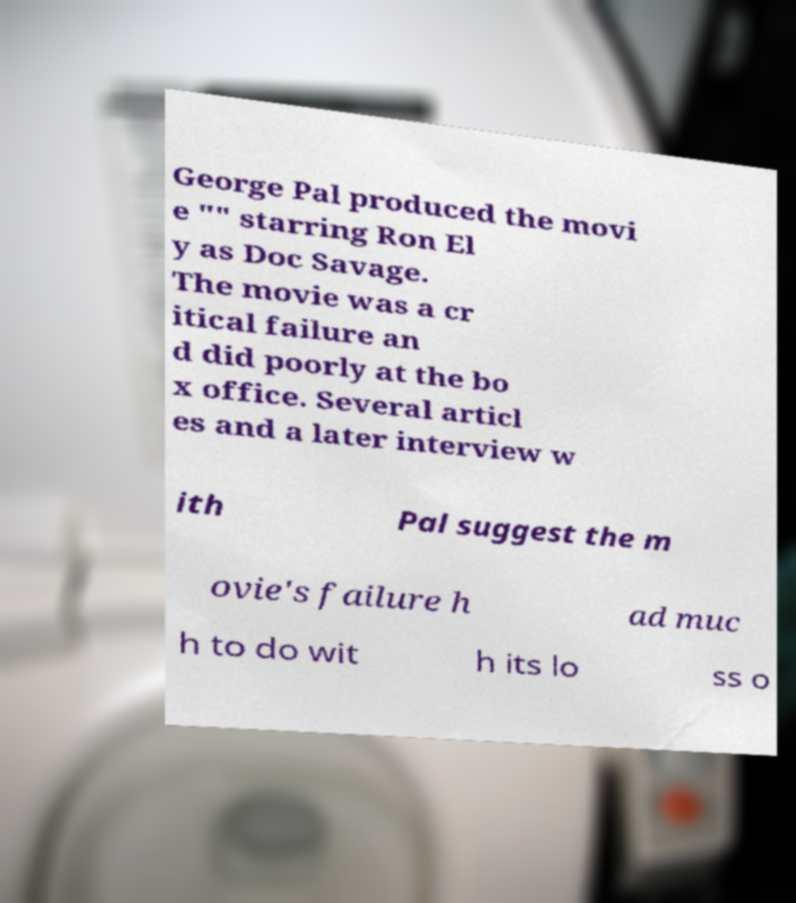Can you read and provide the text displayed in the image?This photo seems to have some interesting text. Can you extract and type it out for me? George Pal produced the movi e "" starring Ron El y as Doc Savage. The movie was a cr itical failure an d did poorly at the bo x office. Several articl es and a later interview w ith Pal suggest the m ovie's failure h ad muc h to do wit h its lo ss o 